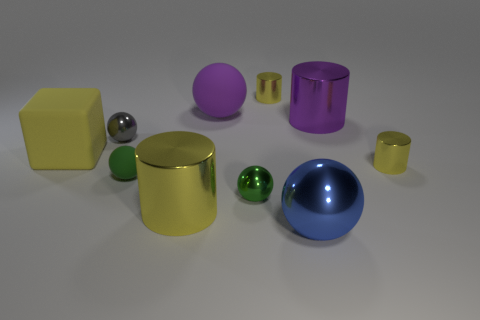Subtract all yellow cylinders. How many were subtracted if there are1yellow cylinders left? 2 Subtract all green blocks. How many yellow cylinders are left? 3 Subtract all purple balls. How many balls are left? 4 Subtract all tiny rubber balls. How many balls are left? 4 Subtract all brown balls. Subtract all red cubes. How many balls are left? 5 Subtract all cylinders. How many objects are left? 6 Add 9 big blue rubber blocks. How many big blue rubber blocks exist? 9 Subtract 0 green cylinders. How many objects are left? 10 Subtract all purple shiny things. Subtract all big blue rubber cubes. How many objects are left? 9 Add 7 purple rubber spheres. How many purple rubber spheres are left? 8 